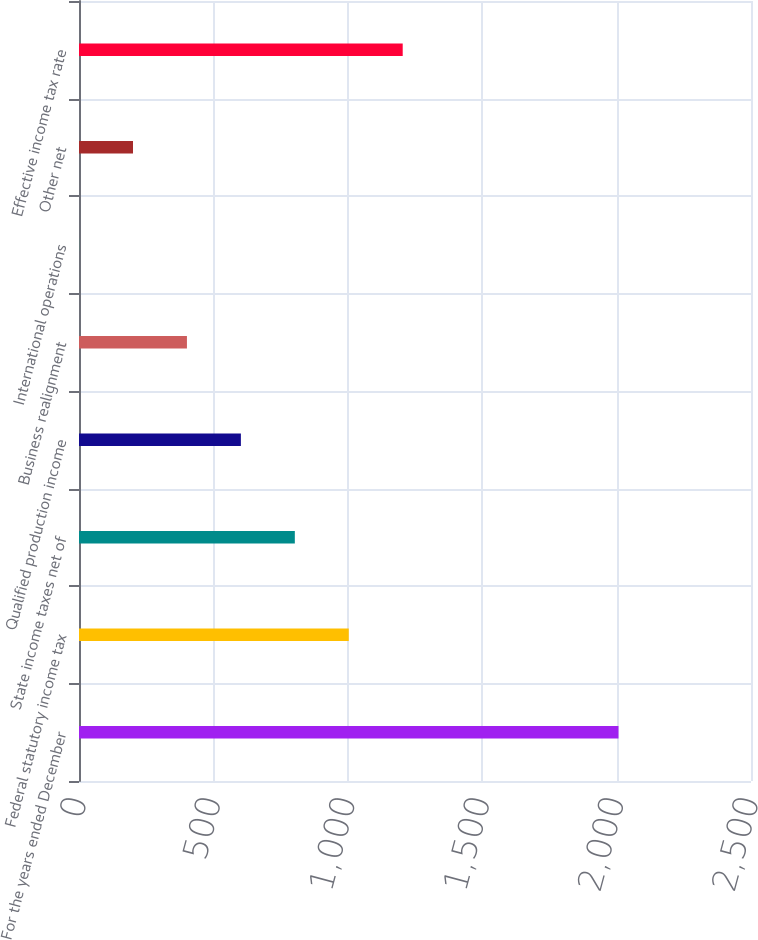<chart> <loc_0><loc_0><loc_500><loc_500><bar_chart><fcel>For the years ended December<fcel>Federal statutory income tax<fcel>State income taxes net of<fcel>Qualified production income<fcel>Business realignment<fcel>International operations<fcel>Other net<fcel>Effective income tax rate<nl><fcel>2007<fcel>1003.6<fcel>802.92<fcel>602.24<fcel>401.56<fcel>0.2<fcel>200.88<fcel>1204.28<nl></chart> 